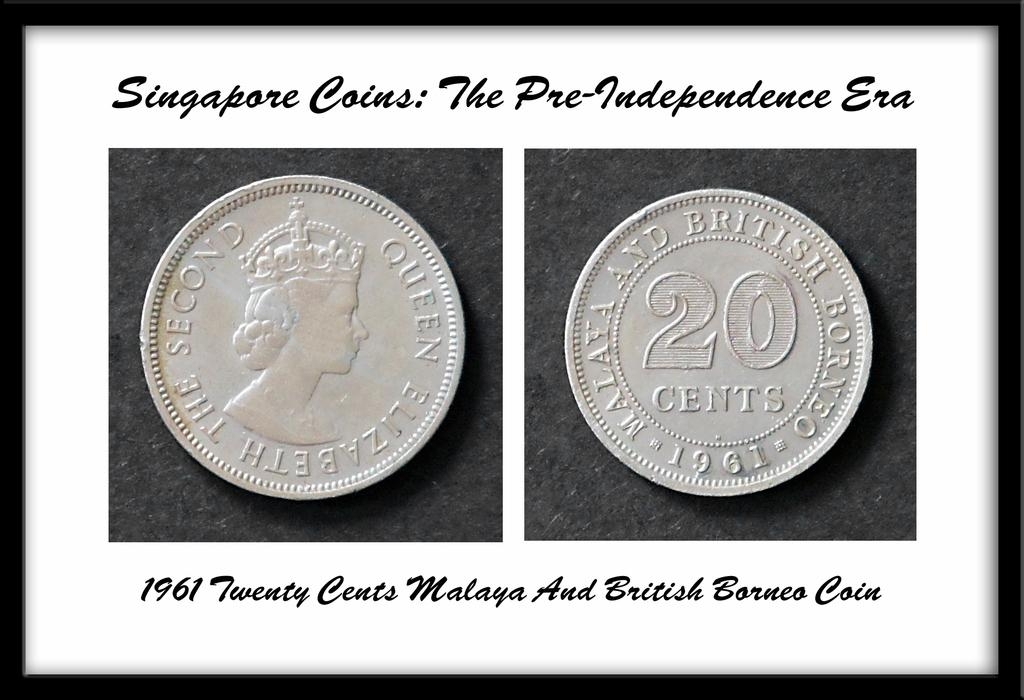<image>
Describe the image concisely. A framed picture of a 1961 Singapore 20 cent coin. 